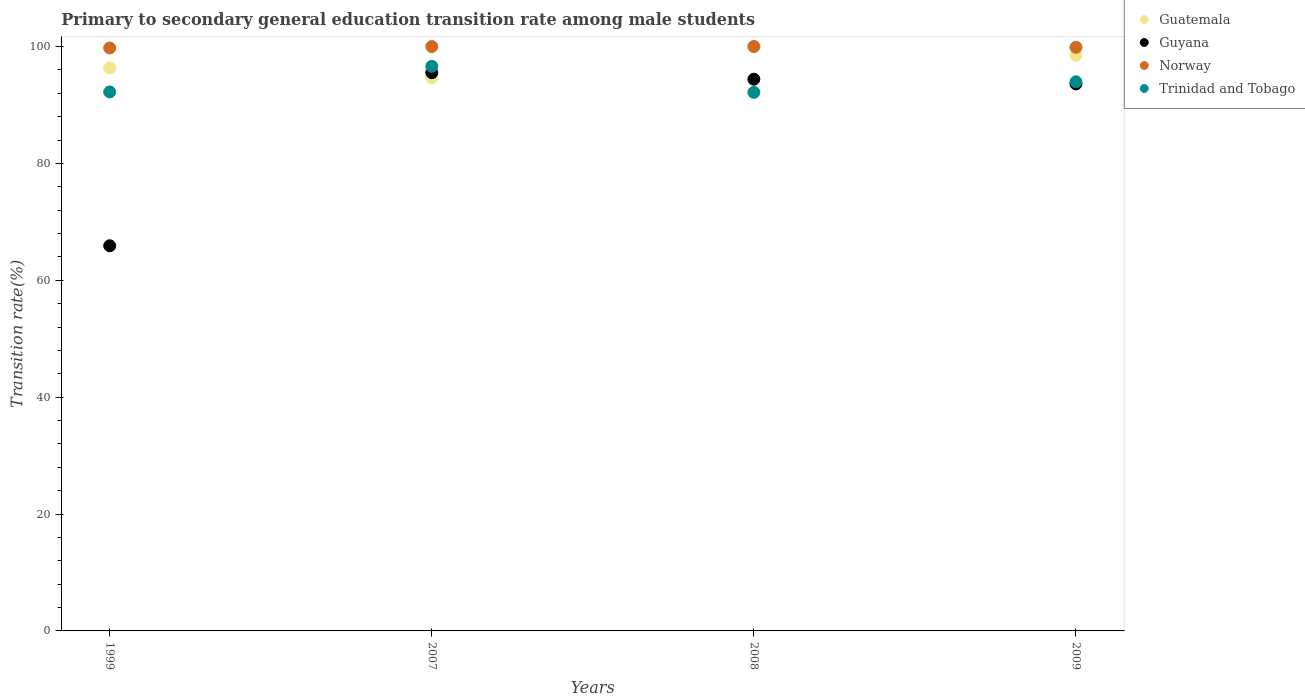How many different coloured dotlines are there?
Your answer should be compact. 4. Is the number of dotlines equal to the number of legend labels?
Your answer should be very brief. Yes. What is the transition rate in Norway in 1999?
Offer a terse response. 99.75. Across all years, what is the maximum transition rate in Guyana?
Your answer should be compact. 95.53. Across all years, what is the minimum transition rate in Guyana?
Your answer should be compact. 65.91. In which year was the transition rate in Norway maximum?
Make the answer very short. 2007. What is the total transition rate in Norway in the graph?
Offer a very short reply. 399.62. What is the difference between the transition rate in Guyana in 2007 and that in 2009?
Give a very brief answer. 1.93. What is the difference between the transition rate in Guatemala in 1999 and the transition rate in Trinidad and Tobago in 2009?
Give a very brief answer. 2.38. What is the average transition rate in Norway per year?
Your response must be concise. 99.9. In the year 2008, what is the difference between the transition rate in Norway and transition rate in Trinidad and Tobago?
Keep it short and to the point. 7.84. What is the ratio of the transition rate in Guatemala in 2007 to that in 2009?
Your answer should be compact. 0.96. Is the transition rate in Guatemala in 1999 less than that in 2009?
Ensure brevity in your answer.  Yes. Is the difference between the transition rate in Norway in 2007 and 2009 greater than the difference between the transition rate in Trinidad and Tobago in 2007 and 2009?
Keep it short and to the point. No. What is the difference between the highest and the second highest transition rate in Trinidad and Tobago?
Provide a succinct answer. 2.64. What is the difference between the highest and the lowest transition rate in Guatemala?
Your answer should be compact. 5.32. In how many years, is the transition rate in Guatemala greater than the average transition rate in Guatemala taken over all years?
Give a very brief answer. 2. Is the sum of the transition rate in Trinidad and Tobago in 2007 and 2008 greater than the maximum transition rate in Guyana across all years?
Provide a succinct answer. Yes. Is it the case that in every year, the sum of the transition rate in Norway and transition rate in Guyana  is greater than the transition rate in Trinidad and Tobago?
Make the answer very short. Yes. Does the transition rate in Trinidad and Tobago monotonically increase over the years?
Provide a succinct answer. No. Is the transition rate in Norway strictly less than the transition rate in Guatemala over the years?
Your response must be concise. No. How many dotlines are there?
Offer a very short reply. 4. What is the difference between two consecutive major ticks on the Y-axis?
Provide a succinct answer. 20. Are the values on the major ticks of Y-axis written in scientific E-notation?
Offer a terse response. No. Where does the legend appear in the graph?
Ensure brevity in your answer.  Top right. How many legend labels are there?
Provide a short and direct response. 4. How are the legend labels stacked?
Your answer should be very brief. Vertical. What is the title of the graph?
Offer a very short reply. Primary to secondary general education transition rate among male students. What is the label or title of the X-axis?
Offer a very short reply. Years. What is the label or title of the Y-axis?
Your answer should be very brief. Transition rate(%). What is the Transition rate(%) of Guatemala in 1999?
Ensure brevity in your answer.  96.35. What is the Transition rate(%) in Guyana in 1999?
Ensure brevity in your answer.  65.91. What is the Transition rate(%) of Norway in 1999?
Offer a terse response. 99.75. What is the Transition rate(%) of Trinidad and Tobago in 1999?
Offer a terse response. 92.23. What is the Transition rate(%) of Guatemala in 2007?
Offer a terse response. 94.68. What is the Transition rate(%) in Guyana in 2007?
Your answer should be compact. 95.53. What is the Transition rate(%) in Norway in 2007?
Make the answer very short. 100. What is the Transition rate(%) of Trinidad and Tobago in 2007?
Provide a short and direct response. 96.61. What is the Transition rate(%) of Guyana in 2008?
Offer a very short reply. 94.41. What is the Transition rate(%) of Trinidad and Tobago in 2008?
Your answer should be compact. 92.16. What is the Transition rate(%) of Guatemala in 2009?
Make the answer very short. 98.51. What is the Transition rate(%) in Guyana in 2009?
Ensure brevity in your answer.  93.6. What is the Transition rate(%) of Norway in 2009?
Make the answer very short. 99.87. What is the Transition rate(%) of Trinidad and Tobago in 2009?
Your answer should be very brief. 93.97. Across all years, what is the maximum Transition rate(%) of Guyana?
Your response must be concise. 95.53. Across all years, what is the maximum Transition rate(%) in Norway?
Make the answer very short. 100. Across all years, what is the maximum Transition rate(%) in Trinidad and Tobago?
Your response must be concise. 96.61. Across all years, what is the minimum Transition rate(%) of Guatemala?
Keep it short and to the point. 94.68. Across all years, what is the minimum Transition rate(%) of Guyana?
Offer a very short reply. 65.91. Across all years, what is the minimum Transition rate(%) of Norway?
Your response must be concise. 99.75. Across all years, what is the minimum Transition rate(%) of Trinidad and Tobago?
Your answer should be compact. 92.16. What is the total Transition rate(%) of Guatemala in the graph?
Provide a succinct answer. 389.55. What is the total Transition rate(%) in Guyana in the graph?
Offer a terse response. 349.45. What is the total Transition rate(%) in Norway in the graph?
Offer a very short reply. 399.62. What is the total Transition rate(%) in Trinidad and Tobago in the graph?
Offer a very short reply. 374.97. What is the difference between the Transition rate(%) of Guatemala in 1999 and that in 2007?
Provide a short and direct response. 1.67. What is the difference between the Transition rate(%) of Guyana in 1999 and that in 2007?
Keep it short and to the point. -29.62. What is the difference between the Transition rate(%) of Norway in 1999 and that in 2007?
Keep it short and to the point. -0.25. What is the difference between the Transition rate(%) of Trinidad and Tobago in 1999 and that in 2007?
Your answer should be compact. -4.38. What is the difference between the Transition rate(%) in Guatemala in 1999 and that in 2008?
Ensure brevity in your answer.  -3.65. What is the difference between the Transition rate(%) in Guyana in 1999 and that in 2008?
Your response must be concise. -28.51. What is the difference between the Transition rate(%) of Norway in 1999 and that in 2008?
Provide a short and direct response. -0.25. What is the difference between the Transition rate(%) in Trinidad and Tobago in 1999 and that in 2008?
Provide a short and direct response. 0.07. What is the difference between the Transition rate(%) of Guatemala in 1999 and that in 2009?
Make the answer very short. -2.16. What is the difference between the Transition rate(%) of Guyana in 1999 and that in 2009?
Provide a succinct answer. -27.7. What is the difference between the Transition rate(%) in Norway in 1999 and that in 2009?
Offer a terse response. -0.11. What is the difference between the Transition rate(%) of Trinidad and Tobago in 1999 and that in 2009?
Make the answer very short. -1.74. What is the difference between the Transition rate(%) of Guatemala in 2007 and that in 2008?
Your response must be concise. -5.32. What is the difference between the Transition rate(%) of Guyana in 2007 and that in 2008?
Make the answer very short. 1.12. What is the difference between the Transition rate(%) in Trinidad and Tobago in 2007 and that in 2008?
Your response must be concise. 4.45. What is the difference between the Transition rate(%) of Guatemala in 2007 and that in 2009?
Your response must be concise. -3.83. What is the difference between the Transition rate(%) in Guyana in 2007 and that in 2009?
Your response must be concise. 1.93. What is the difference between the Transition rate(%) in Norway in 2007 and that in 2009?
Make the answer very short. 0.13. What is the difference between the Transition rate(%) in Trinidad and Tobago in 2007 and that in 2009?
Give a very brief answer. 2.64. What is the difference between the Transition rate(%) of Guatemala in 2008 and that in 2009?
Give a very brief answer. 1.49. What is the difference between the Transition rate(%) of Guyana in 2008 and that in 2009?
Your answer should be compact. 0.81. What is the difference between the Transition rate(%) in Norway in 2008 and that in 2009?
Offer a very short reply. 0.13. What is the difference between the Transition rate(%) of Trinidad and Tobago in 2008 and that in 2009?
Your answer should be compact. -1.81. What is the difference between the Transition rate(%) of Guatemala in 1999 and the Transition rate(%) of Guyana in 2007?
Give a very brief answer. 0.82. What is the difference between the Transition rate(%) in Guatemala in 1999 and the Transition rate(%) in Norway in 2007?
Provide a short and direct response. -3.65. What is the difference between the Transition rate(%) of Guatemala in 1999 and the Transition rate(%) of Trinidad and Tobago in 2007?
Ensure brevity in your answer.  -0.26. What is the difference between the Transition rate(%) of Guyana in 1999 and the Transition rate(%) of Norway in 2007?
Your answer should be compact. -34.09. What is the difference between the Transition rate(%) of Guyana in 1999 and the Transition rate(%) of Trinidad and Tobago in 2007?
Your answer should be compact. -30.7. What is the difference between the Transition rate(%) in Norway in 1999 and the Transition rate(%) in Trinidad and Tobago in 2007?
Provide a succinct answer. 3.14. What is the difference between the Transition rate(%) in Guatemala in 1999 and the Transition rate(%) in Guyana in 2008?
Keep it short and to the point. 1.94. What is the difference between the Transition rate(%) in Guatemala in 1999 and the Transition rate(%) in Norway in 2008?
Make the answer very short. -3.65. What is the difference between the Transition rate(%) of Guatemala in 1999 and the Transition rate(%) of Trinidad and Tobago in 2008?
Offer a very short reply. 4.2. What is the difference between the Transition rate(%) of Guyana in 1999 and the Transition rate(%) of Norway in 2008?
Keep it short and to the point. -34.09. What is the difference between the Transition rate(%) of Guyana in 1999 and the Transition rate(%) of Trinidad and Tobago in 2008?
Offer a terse response. -26.25. What is the difference between the Transition rate(%) in Norway in 1999 and the Transition rate(%) in Trinidad and Tobago in 2008?
Your answer should be compact. 7.6. What is the difference between the Transition rate(%) in Guatemala in 1999 and the Transition rate(%) in Guyana in 2009?
Offer a very short reply. 2.75. What is the difference between the Transition rate(%) of Guatemala in 1999 and the Transition rate(%) of Norway in 2009?
Offer a very short reply. -3.51. What is the difference between the Transition rate(%) of Guatemala in 1999 and the Transition rate(%) of Trinidad and Tobago in 2009?
Give a very brief answer. 2.38. What is the difference between the Transition rate(%) of Guyana in 1999 and the Transition rate(%) of Norway in 2009?
Keep it short and to the point. -33.96. What is the difference between the Transition rate(%) in Guyana in 1999 and the Transition rate(%) in Trinidad and Tobago in 2009?
Your answer should be very brief. -28.06. What is the difference between the Transition rate(%) in Norway in 1999 and the Transition rate(%) in Trinidad and Tobago in 2009?
Ensure brevity in your answer.  5.78. What is the difference between the Transition rate(%) in Guatemala in 2007 and the Transition rate(%) in Guyana in 2008?
Provide a succinct answer. 0.27. What is the difference between the Transition rate(%) in Guatemala in 2007 and the Transition rate(%) in Norway in 2008?
Offer a terse response. -5.32. What is the difference between the Transition rate(%) of Guatemala in 2007 and the Transition rate(%) of Trinidad and Tobago in 2008?
Your answer should be compact. 2.52. What is the difference between the Transition rate(%) of Guyana in 2007 and the Transition rate(%) of Norway in 2008?
Your answer should be compact. -4.47. What is the difference between the Transition rate(%) in Guyana in 2007 and the Transition rate(%) in Trinidad and Tobago in 2008?
Your answer should be compact. 3.37. What is the difference between the Transition rate(%) in Norway in 2007 and the Transition rate(%) in Trinidad and Tobago in 2008?
Offer a terse response. 7.84. What is the difference between the Transition rate(%) in Guatemala in 2007 and the Transition rate(%) in Guyana in 2009?
Your response must be concise. 1.08. What is the difference between the Transition rate(%) in Guatemala in 2007 and the Transition rate(%) in Norway in 2009?
Ensure brevity in your answer.  -5.19. What is the difference between the Transition rate(%) in Guatemala in 2007 and the Transition rate(%) in Trinidad and Tobago in 2009?
Your response must be concise. 0.71. What is the difference between the Transition rate(%) in Guyana in 2007 and the Transition rate(%) in Norway in 2009?
Your answer should be compact. -4.34. What is the difference between the Transition rate(%) in Guyana in 2007 and the Transition rate(%) in Trinidad and Tobago in 2009?
Your answer should be compact. 1.56. What is the difference between the Transition rate(%) in Norway in 2007 and the Transition rate(%) in Trinidad and Tobago in 2009?
Provide a succinct answer. 6.03. What is the difference between the Transition rate(%) in Guatemala in 2008 and the Transition rate(%) in Guyana in 2009?
Your answer should be very brief. 6.4. What is the difference between the Transition rate(%) in Guatemala in 2008 and the Transition rate(%) in Norway in 2009?
Make the answer very short. 0.13. What is the difference between the Transition rate(%) of Guatemala in 2008 and the Transition rate(%) of Trinidad and Tobago in 2009?
Offer a terse response. 6.03. What is the difference between the Transition rate(%) in Guyana in 2008 and the Transition rate(%) in Norway in 2009?
Your answer should be compact. -5.46. What is the difference between the Transition rate(%) of Guyana in 2008 and the Transition rate(%) of Trinidad and Tobago in 2009?
Give a very brief answer. 0.44. What is the difference between the Transition rate(%) of Norway in 2008 and the Transition rate(%) of Trinidad and Tobago in 2009?
Make the answer very short. 6.03. What is the average Transition rate(%) in Guatemala per year?
Provide a succinct answer. 97.39. What is the average Transition rate(%) in Guyana per year?
Provide a short and direct response. 87.36. What is the average Transition rate(%) of Norway per year?
Provide a succinct answer. 99.9. What is the average Transition rate(%) of Trinidad and Tobago per year?
Provide a succinct answer. 93.74. In the year 1999, what is the difference between the Transition rate(%) in Guatemala and Transition rate(%) in Guyana?
Your response must be concise. 30.45. In the year 1999, what is the difference between the Transition rate(%) in Guatemala and Transition rate(%) in Norway?
Offer a very short reply. -3.4. In the year 1999, what is the difference between the Transition rate(%) of Guatemala and Transition rate(%) of Trinidad and Tobago?
Provide a succinct answer. 4.12. In the year 1999, what is the difference between the Transition rate(%) in Guyana and Transition rate(%) in Norway?
Keep it short and to the point. -33.85. In the year 1999, what is the difference between the Transition rate(%) in Guyana and Transition rate(%) in Trinidad and Tobago?
Provide a succinct answer. -26.32. In the year 1999, what is the difference between the Transition rate(%) of Norway and Transition rate(%) of Trinidad and Tobago?
Provide a short and direct response. 7.52. In the year 2007, what is the difference between the Transition rate(%) of Guatemala and Transition rate(%) of Guyana?
Give a very brief answer. -0.85. In the year 2007, what is the difference between the Transition rate(%) of Guatemala and Transition rate(%) of Norway?
Offer a terse response. -5.32. In the year 2007, what is the difference between the Transition rate(%) of Guatemala and Transition rate(%) of Trinidad and Tobago?
Your answer should be very brief. -1.93. In the year 2007, what is the difference between the Transition rate(%) in Guyana and Transition rate(%) in Norway?
Offer a very short reply. -4.47. In the year 2007, what is the difference between the Transition rate(%) of Guyana and Transition rate(%) of Trinidad and Tobago?
Your answer should be compact. -1.08. In the year 2007, what is the difference between the Transition rate(%) in Norway and Transition rate(%) in Trinidad and Tobago?
Your answer should be compact. 3.39. In the year 2008, what is the difference between the Transition rate(%) in Guatemala and Transition rate(%) in Guyana?
Ensure brevity in your answer.  5.59. In the year 2008, what is the difference between the Transition rate(%) in Guatemala and Transition rate(%) in Norway?
Ensure brevity in your answer.  0. In the year 2008, what is the difference between the Transition rate(%) of Guatemala and Transition rate(%) of Trinidad and Tobago?
Offer a terse response. 7.84. In the year 2008, what is the difference between the Transition rate(%) in Guyana and Transition rate(%) in Norway?
Make the answer very short. -5.59. In the year 2008, what is the difference between the Transition rate(%) in Guyana and Transition rate(%) in Trinidad and Tobago?
Offer a terse response. 2.25. In the year 2008, what is the difference between the Transition rate(%) in Norway and Transition rate(%) in Trinidad and Tobago?
Provide a short and direct response. 7.84. In the year 2009, what is the difference between the Transition rate(%) in Guatemala and Transition rate(%) in Guyana?
Make the answer very short. 4.91. In the year 2009, what is the difference between the Transition rate(%) of Guatemala and Transition rate(%) of Norway?
Your answer should be very brief. -1.35. In the year 2009, what is the difference between the Transition rate(%) in Guatemala and Transition rate(%) in Trinidad and Tobago?
Your answer should be compact. 4.54. In the year 2009, what is the difference between the Transition rate(%) of Guyana and Transition rate(%) of Norway?
Keep it short and to the point. -6.26. In the year 2009, what is the difference between the Transition rate(%) of Guyana and Transition rate(%) of Trinidad and Tobago?
Provide a short and direct response. -0.37. In the year 2009, what is the difference between the Transition rate(%) of Norway and Transition rate(%) of Trinidad and Tobago?
Your response must be concise. 5.9. What is the ratio of the Transition rate(%) of Guatemala in 1999 to that in 2007?
Your answer should be compact. 1.02. What is the ratio of the Transition rate(%) in Guyana in 1999 to that in 2007?
Make the answer very short. 0.69. What is the ratio of the Transition rate(%) in Norway in 1999 to that in 2007?
Offer a terse response. 1. What is the ratio of the Transition rate(%) of Trinidad and Tobago in 1999 to that in 2007?
Your answer should be compact. 0.95. What is the ratio of the Transition rate(%) of Guatemala in 1999 to that in 2008?
Provide a short and direct response. 0.96. What is the ratio of the Transition rate(%) in Guyana in 1999 to that in 2008?
Your response must be concise. 0.7. What is the ratio of the Transition rate(%) of Trinidad and Tobago in 1999 to that in 2008?
Provide a succinct answer. 1. What is the ratio of the Transition rate(%) of Guatemala in 1999 to that in 2009?
Your answer should be very brief. 0.98. What is the ratio of the Transition rate(%) of Guyana in 1999 to that in 2009?
Offer a very short reply. 0.7. What is the ratio of the Transition rate(%) of Norway in 1999 to that in 2009?
Offer a very short reply. 1. What is the ratio of the Transition rate(%) of Trinidad and Tobago in 1999 to that in 2009?
Give a very brief answer. 0.98. What is the ratio of the Transition rate(%) in Guatemala in 2007 to that in 2008?
Offer a very short reply. 0.95. What is the ratio of the Transition rate(%) of Guyana in 2007 to that in 2008?
Offer a terse response. 1.01. What is the ratio of the Transition rate(%) of Trinidad and Tobago in 2007 to that in 2008?
Your answer should be compact. 1.05. What is the ratio of the Transition rate(%) of Guatemala in 2007 to that in 2009?
Keep it short and to the point. 0.96. What is the ratio of the Transition rate(%) in Guyana in 2007 to that in 2009?
Give a very brief answer. 1.02. What is the ratio of the Transition rate(%) in Trinidad and Tobago in 2007 to that in 2009?
Make the answer very short. 1.03. What is the ratio of the Transition rate(%) in Guatemala in 2008 to that in 2009?
Give a very brief answer. 1.02. What is the ratio of the Transition rate(%) in Guyana in 2008 to that in 2009?
Your response must be concise. 1.01. What is the ratio of the Transition rate(%) of Trinidad and Tobago in 2008 to that in 2009?
Give a very brief answer. 0.98. What is the difference between the highest and the second highest Transition rate(%) of Guatemala?
Your answer should be very brief. 1.49. What is the difference between the highest and the second highest Transition rate(%) of Guyana?
Your answer should be compact. 1.12. What is the difference between the highest and the second highest Transition rate(%) of Norway?
Your answer should be compact. 0. What is the difference between the highest and the second highest Transition rate(%) of Trinidad and Tobago?
Provide a short and direct response. 2.64. What is the difference between the highest and the lowest Transition rate(%) of Guatemala?
Provide a succinct answer. 5.32. What is the difference between the highest and the lowest Transition rate(%) in Guyana?
Offer a terse response. 29.62. What is the difference between the highest and the lowest Transition rate(%) of Norway?
Your answer should be compact. 0.25. What is the difference between the highest and the lowest Transition rate(%) in Trinidad and Tobago?
Offer a terse response. 4.45. 